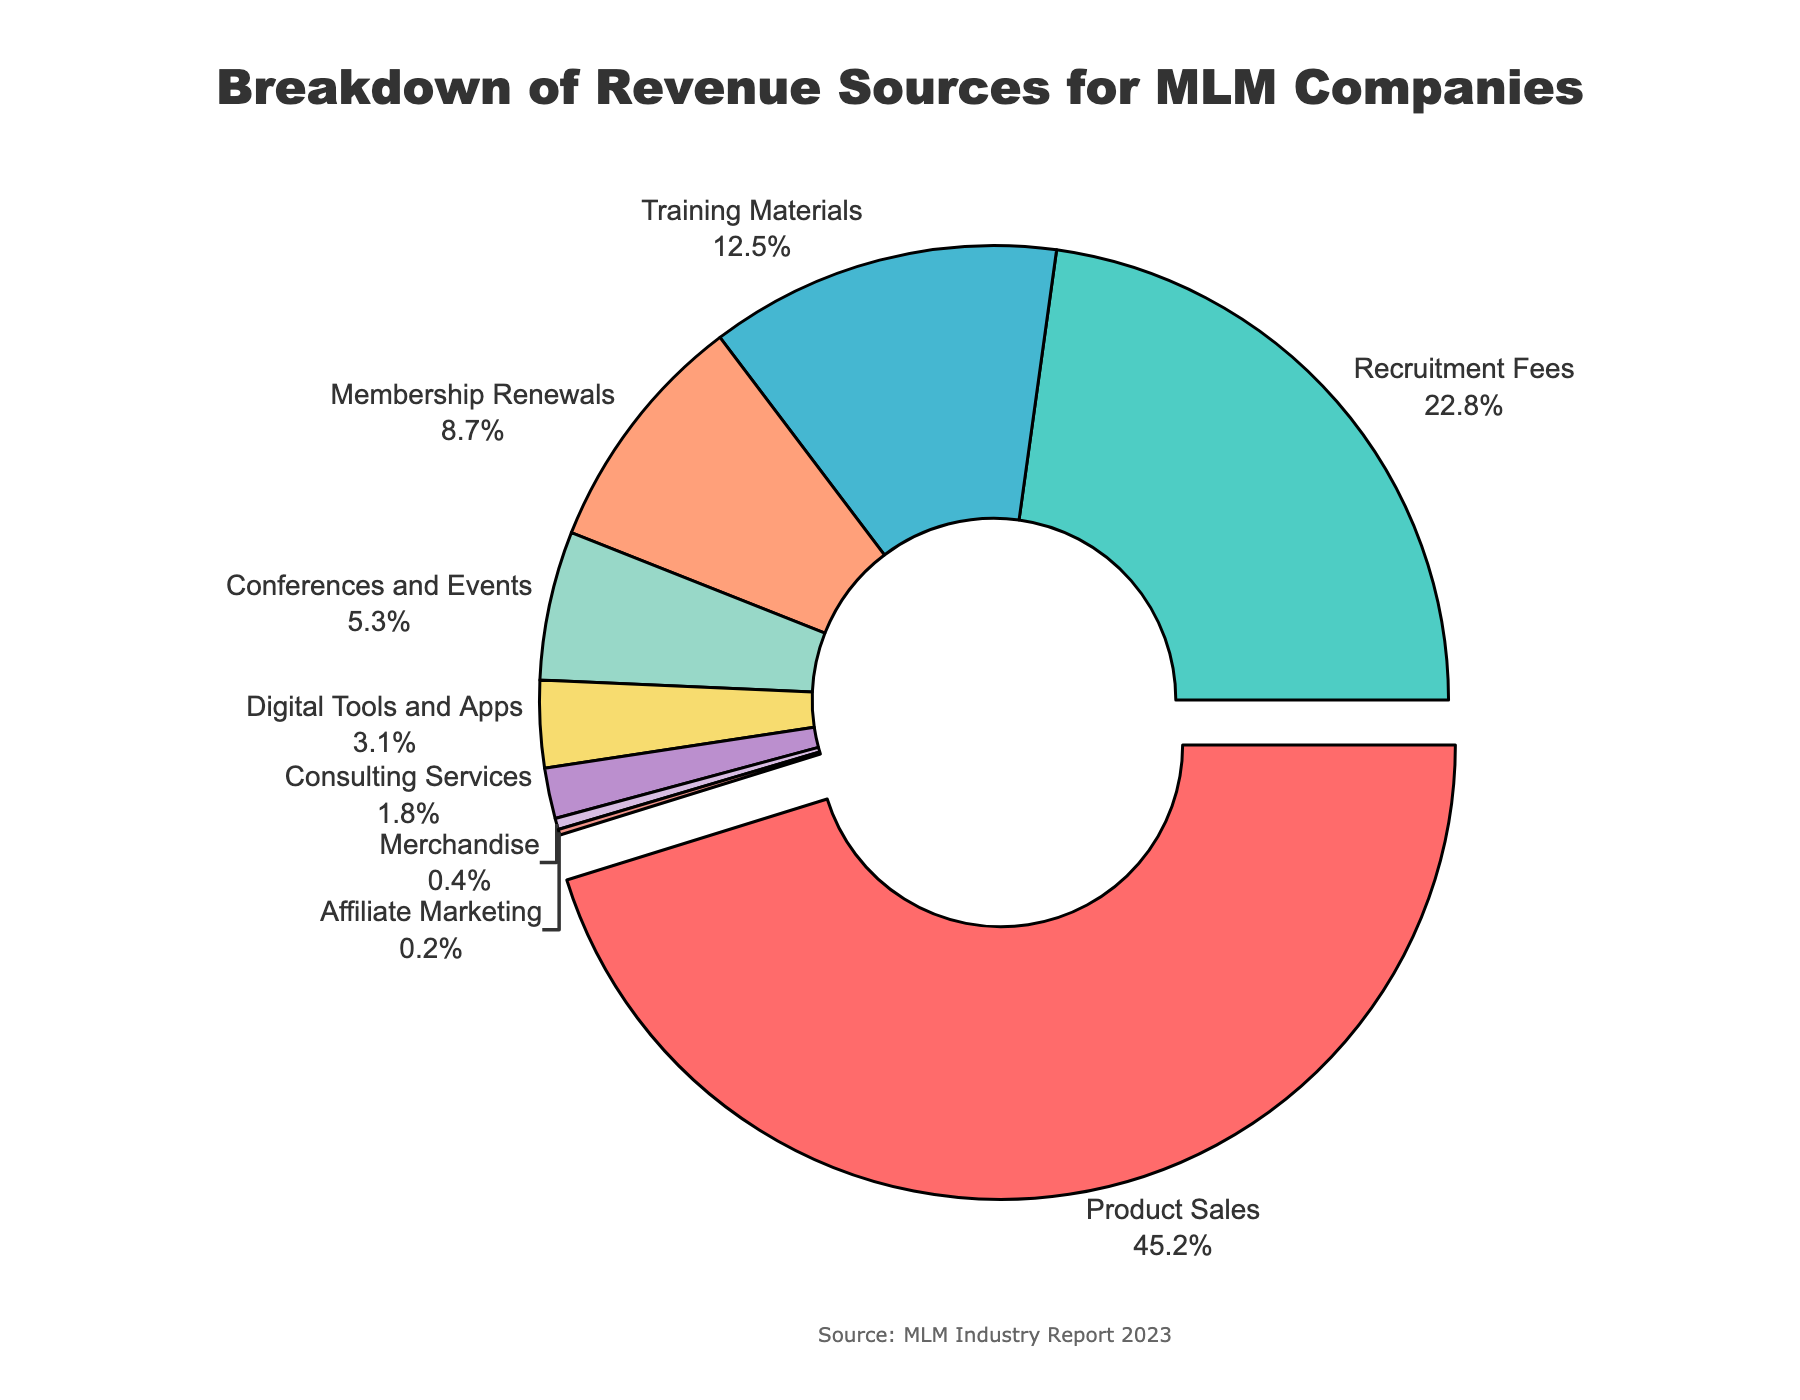what is the source of the highest revenue for MLM companies? The pie chart shows that "Product Sales" has the largest slice and is also pulled out from the rest for emphasis. It contributes 45.2% of the revenue.
Answer: Product Sales What percentage of revenue comes from sources other than Product Sales and Recruitment Fees? The total percentage from "Product Sales" and "Recruitment Fees" is 45.2% + 22.8% = 68%. Thus, the percentage from other sources is 100% - 68% = 32%.
Answer: 32% Which two revenue sources together contribute around one-third of the total revenue? "Training Materials" contributes 12.5% and "Membership Renewals" contributes 8.7%. Together, they contribute 12.5% + 8.7% = 21.2%, and "Conferences and Events" contributes 5.3%. Together with "Membership Renewals", they contribute 8.7% + 5.3% = 14%. "Training Materials" (12.5%), "Membership Renewals" (8.7%), and "Conferences and Events" (5.3%) together contribute 26.5%, which is closest to one-third.
Answer: Training Materials and Membership Renewals; or Training Materials, Membership Renewals, and Conferences and Events Which revenue source has the smallest percentage? The pie chart shows that "Affiliate Marketing" has the smallest slice, contributing only 0.2% to the total revenue.
Answer: Affiliate Marketing Which revenue sources comprise less than 5% of the total revenue? According to the pie chart, "Digital Tools and Apps" (3.1%), "Consulting Services" (1.8%), "Merchandise" (0.4%), and "Affiliate Marketing" (0.2%) each contribute less than 5% to the total revenue.
Answer: Digital Tools and Apps, Consulting Services, Merchandise, and Affiliate Marketing How much more revenue is generated from Product Sales compared to Membership Renewals? "Product Sales" contribute 45.2%, while "Membership Renewals" contribute 8.7%. The difference is 45.2% - 8.7% = 36.5%.
Answer: 36.5% What is the combined revenue percentage from Training Materials, Membership Renewals, and Conferences and Events? Adding the percentages from "Training Materials" (12.5%), "Membership Renewals" (8.7%), and "Conferences and Events" (5.3%) gives: 12.5% + 8.7% + 5.3% = 26.5%.
Answer: 26.5% Compare the revenue from Recruitment Fees and Digital Tools and Apps. Which one is larger and by how much? "Recruitment Fees" generate 22.8%, and "Digital Tools and Apps" generate 3.1%. The difference is 22.8% - 3.1% = 19.7%.
Answer: Recruitment Fees by 19.7% What color represents the revenue source for Conferences and Events on the pie chart? The segment with conferences and events is colored in a shade of yellowish brown.
Answer: Yellowish brown / F7DC6F 